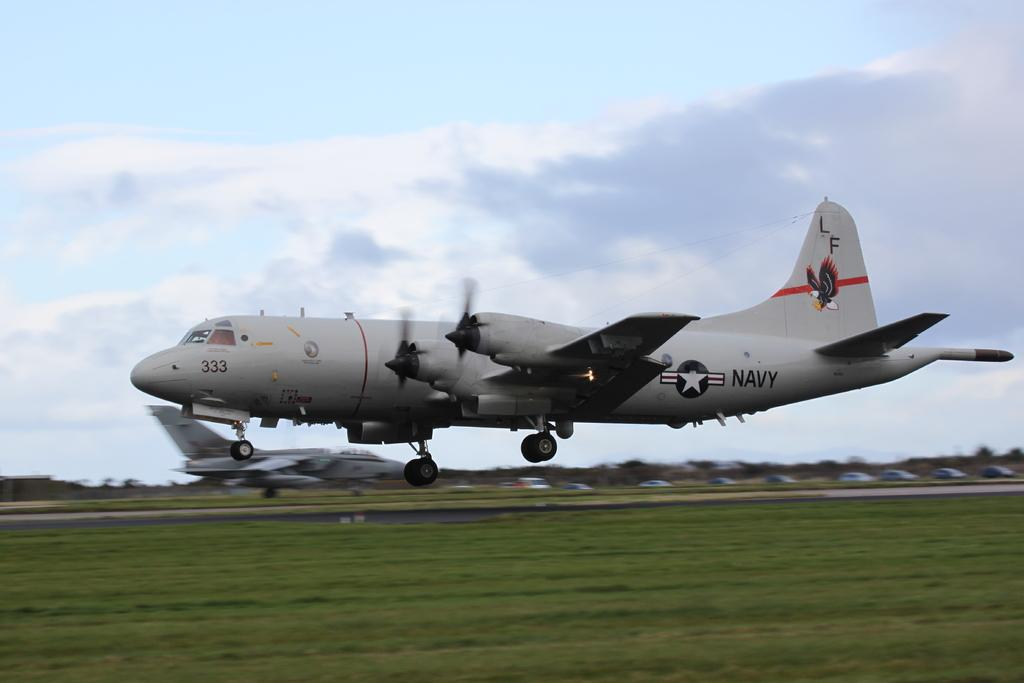<image>
Provide a brief description of the given image. US Navy plane that has the emblem LF on the tail. 